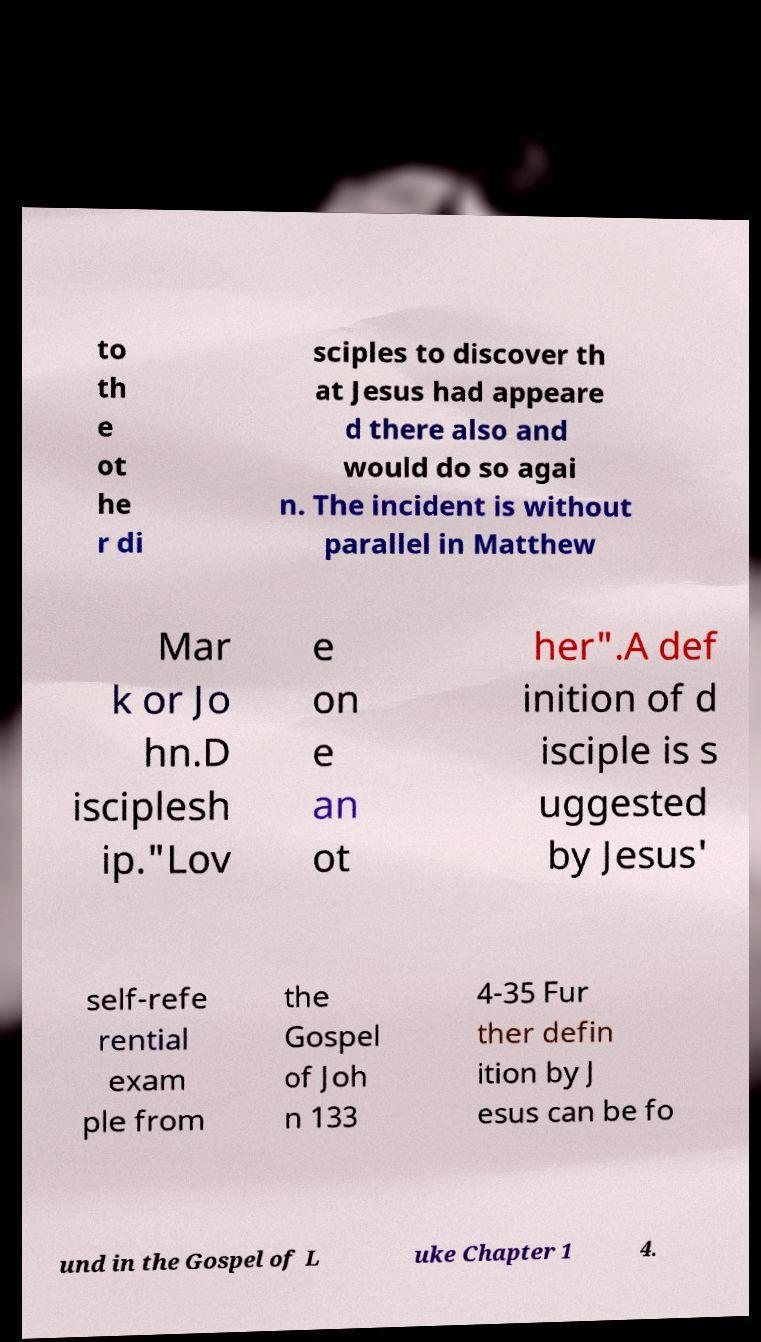Can you read and provide the text displayed in the image?This photo seems to have some interesting text. Can you extract and type it out for me? to th e ot he r di sciples to discover th at Jesus had appeare d there also and would do so agai n. The incident is without parallel in Matthew Mar k or Jo hn.D isciplesh ip."Lov e on e an ot her".A def inition of d isciple is s uggested by Jesus' self-refe rential exam ple from the Gospel of Joh n 133 4-35 Fur ther defin ition by J esus can be fo und in the Gospel of L uke Chapter 1 4. 